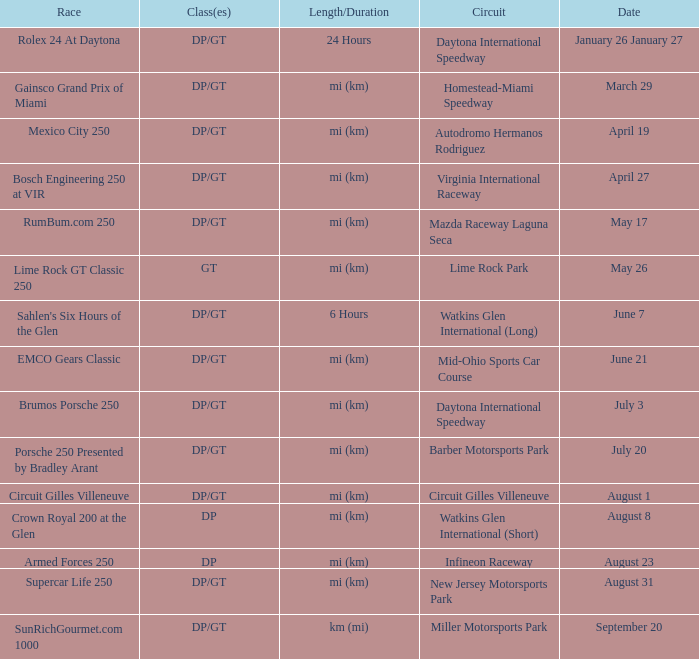What are the class types for the circuit hosting the mazda raceway laguna seca race? DP/GT. 